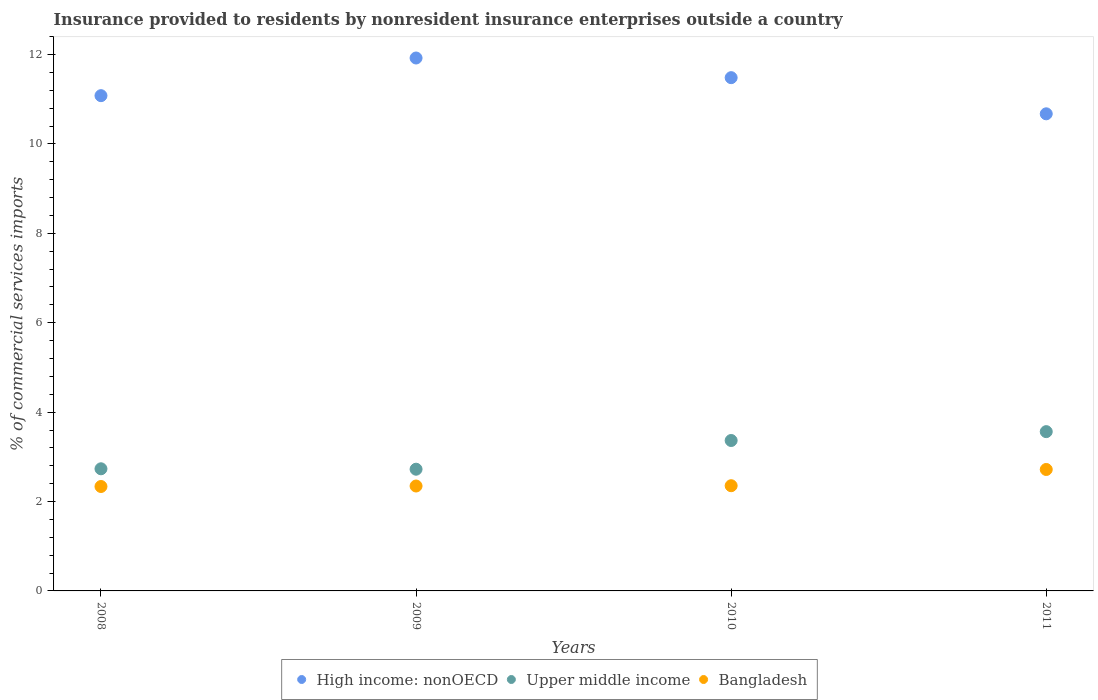What is the Insurance provided to residents in High income: nonOECD in 2011?
Offer a terse response. 10.67. Across all years, what is the maximum Insurance provided to residents in Upper middle income?
Your response must be concise. 3.56. Across all years, what is the minimum Insurance provided to residents in Upper middle income?
Offer a terse response. 2.72. In which year was the Insurance provided to residents in High income: nonOECD minimum?
Make the answer very short. 2011. What is the total Insurance provided to residents in High income: nonOECD in the graph?
Give a very brief answer. 45.16. What is the difference between the Insurance provided to residents in High income: nonOECD in 2008 and that in 2011?
Your answer should be compact. 0.41. What is the difference between the Insurance provided to residents in High income: nonOECD in 2011 and the Insurance provided to residents in Bangladesh in 2008?
Provide a short and direct response. 8.34. What is the average Insurance provided to residents in Bangladesh per year?
Your response must be concise. 2.44. In the year 2010, what is the difference between the Insurance provided to residents in High income: nonOECD and Insurance provided to residents in Bangladesh?
Provide a short and direct response. 9.13. In how many years, is the Insurance provided to residents in Bangladesh greater than 9.2 %?
Keep it short and to the point. 0. What is the ratio of the Insurance provided to residents in Bangladesh in 2009 to that in 2011?
Provide a succinct answer. 0.86. Is the difference between the Insurance provided to residents in High income: nonOECD in 2008 and 2011 greater than the difference between the Insurance provided to residents in Bangladesh in 2008 and 2011?
Ensure brevity in your answer.  Yes. What is the difference between the highest and the second highest Insurance provided to residents in High income: nonOECD?
Give a very brief answer. 0.44. What is the difference between the highest and the lowest Insurance provided to residents in High income: nonOECD?
Your response must be concise. 1.25. In how many years, is the Insurance provided to residents in High income: nonOECD greater than the average Insurance provided to residents in High income: nonOECD taken over all years?
Your response must be concise. 2. Does the Insurance provided to residents in High income: nonOECD monotonically increase over the years?
Your answer should be very brief. No. Is the Insurance provided to residents in Bangladesh strictly greater than the Insurance provided to residents in High income: nonOECD over the years?
Provide a succinct answer. No. How many years are there in the graph?
Your answer should be compact. 4. What is the difference between two consecutive major ticks on the Y-axis?
Offer a terse response. 2. Does the graph contain grids?
Offer a terse response. No. Where does the legend appear in the graph?
Provide a short and direct response. Bottom center. How are the legend labels stacked?
Your response must be concise. Horizontal. What is the title of the graph?
Offer a very short reply. Insurance provided to residents by nonresident insurance enterprises outside a country. Does "Brazil" appear as one of the legend labels in the graph?
Your answer should be very brief. No. What is the label or title of the Y-axis?
Keep it short and to the point. % of commercial services imports. What is the % of commercial services imports of High income: nonOECD in 2008?
Provide a succinct answer. 11.08. What is the % of commercial services imports of Upper middle income in 2008?
Your response must be concise. 2.73. What is the % of commercial services imports of Bangladesh in 2008?
Your answer should be very brief. 2.34. What is the % of commercial services imports in High income: nonOECD in 2009?
Make the answer very short. 11.92. What is the % of commercial services imports of Upper middle income in 2009?
Provide a short and direct response. 2.72. What is the % of commercial services imports of Bangladesh in 2009?
Your response must be concise. 2.35. What is the % of commercial services imports in High income: nonOECD in 2010?
Offer a very short reply. 11.48. What is the % of commercial services imports of Upper middle income in 2010?
Your answer should be compact. 3.37. What is the % of commercial services imports in Bangladesh in 2010?
Your response must be concise. 2.35. What is the % of commercial services imports in High income: nonOECD in 2011?
Your answer should be compact. 10.67. What is the % of commercial services imports of Upper middle income in 2011?
Keep it short and to the point. 3.56. What is the % of commercial services imports of Bangladesh in 2011?
Offer a terse response. 2.72. Across all years, what is the maximum % of commercial services imports in High income: nonOECD?
Your answer should be very brief. 11.92. Across all years, what is the maximum % of commercial services imports of Upper middle income?
Provide a short and direct response. 3.56. Across all years, what is the maximum % of commercial services imports of Bangladesh?
Ensure brevity in your answer.  2.72. Across all years, what is the minimum % of commercial services imports in High income: nonOECD?
Give a very brief answer. 10.67. Across all years, what is the minimum % of commercial services imports in Upper middle income?
Give a very brief answer. 2.72. Across all years, what is the minimum % of commercial services imports in Bangladesh?
Make the answer very short. 2.34. What is the total % of commercial services imports of High income: nonOECD in the graph?
Ensure brevity in your answer.  45.16. What is the total % of commercial services imports in Upper middle income in the graph?
Make the answer very short. 12.38. What is the total % of commercial services imports in Bangladesh in the graph?
Give a very brief answer. 9.75. What is the difference between the % of commercial services imports in High income: nonOECD in 2008 and that in 2009?
Offer a very short reply. -0.84. What is the difference between the % of commercial services imports of Upper middle income in 2008 and that in 2009?
Give a very brief answer. 0.01. What is the difference between the % of commercial services imports in Bangladesh in 2008 and that in 2009?
Make the answer very short. -0.01. What is the difference between the % of commercial services imports of High income: nonOECD in 2008 and that in 2010?
Your answer should be very brief. -0.4. What is the difference between the % of commercial services imports of Upper middle income in 2008 and that in 2010?
Keep it short and to the point. -0.63. What is the difference between the % of commercial services imports of Bangladesh in 2008 and that in 2010?
Your response must be concise. -0.02. What is the difference between the % of commercial services imports in High income: nonOECD in 2008 and that in 2011?
Offer a very short reply. 0.41. What is the difference between the % of commercial services imports in Upper middle income in 2008 and that in 2011?
Your answer should be compact. -0.83. What is the difference between the % of commercial services imports in Bangladesh in 2008 and that in 2011?
Your answer should be compact. -0.38. What is the difference between the % of commercial services imports of High income: nonOECD in 2009 and that in 2010?
Ensure brevity in your answer.  0.44. What is the difference between the % of commercial services imports of Upper middle income in 2009 and that in 2010?
Keep it short and to the point. -0.64. What is the difference between the % of commercial services imports in Bangladesh in 2009 and that in 2010?
Provide a short and direct response. -0.01. What is the difference between the % of commercial services imports in High income: nonOECD in 2009 and that in 2011?
Provide a short and direct response. 1.25. What is the difference between the % of commercial services imports in Upper middle income in 2009 and that in 2011?
Offer a terse response. -0.84. What is the difference between the % of commercial services imports in Bangladesh in 2009 and that in 2011?
Your answer should be compact. -0.37. What is the difference between the % of commercial services imports in High income: nonOECD in 2010 and that in 2011?
Provide a short and direct response. 0.81. What is the difference between the % of commercial services imports of Upper middle income in 2010 and that in 2011?
Make the answer very short. -0.2. What is the difference between the % of commercial services imports of Bangladesh in 2010 and that in 2011?
Your response must be concise. -0.36. What is the difference between the % of commercial services imports in High income: nonOECD in 2008 and the % of commercial services imports in Upper middle income in 2009?
Keep it short and to the point. 8.36. What is the difference between the % of commercial services imports of High income: nonOECD in 2008 and the % of commercial services imports of Bangladesh in 2009?
Provide a short and direct response. 8.73. What is the difference between the % of commercial services imports in Upper middle income in 2008 and the % of commercial services imports in Bangladesh in 2009?
Provide a succinct answer. 0.39. What is the difference between the % of commercial services imports of High income: nonOECD in 2008 and the % of commercial services imports of Upper middle income in 2010?
Make the answer very short. 7.72. What is the difference between the % of commercial services imports of High income: nonOECD in 2008 and the % of commercial services imports of Bangladesh in 2010?
Your answer should be very brief. 8.73. What is the difference between the % of commercial services imports in Upper middle income in 2008 and the % of commercial services imports in Bangladesh in 2010?
Keep it short and to the point. 0.38. What is the difference between the % of commercial services imports in High income: nonOECD in 2008 and the % of commercial services imports in Upper middle income in 2011?
Your answer should be very brief. 7.52. What is the difference between the % of commercial services imports of High income: nonOECD in 2008 and the % of commercial services imports of Bangladesh in 2011?
Provide a short and direct response. 8.36. What is the difference between the % of commercial services imports in Upper middle income in 2008 and the % of commercial services imports in Bangladesh in 2011?
Your answer should be very brief. 0.02. What is the difference between the % of commercial services imports in High income: nonOECD in 2009 and the % of commercial services imports in Upper middle income in 2010?
Give a very brief answer. 8.56. What is the difference between the % of commercial services imports in High income: nonOECD in 2009 and the % of commercial services imports in Bangladesh in 2010?
Give a very brief answer. 9.57. What is the difference between the % of commercial services imports of Upper middle income in 2009 and the % of commercial services imports of Bangladesh in 2010?
Offer a terse response. 0.37. What is the difference between the % of commercial services imports of High income: nonOECD in 2009 and the % of commercial services imports of Upper middle income in 2011?
Ensure brevity in your answer.  8.36. What is the difference between the % of commercial services imports in High income: nonOECD in 2009 and the % of commercial services imports in Bangladesh in 2011?
Your answer should be very brief. 9.21. What is the difference between the % of commercial services imports of Upper middle income in 2009 and the % of commercial services imports of Bangladesh in 2011?
Give a very brief answer. 0.01. What is the difference between the % of commercial services imports of High income: nonOECD in 2010 and the % of commercial services imports of Upper middle income in 2011?
Make the answer very short. 7.92. What is the difference between the % of commercial services imports of High income: nonOECD in 2010 and the % of commercial services imports of Bangladesh in 2011?
Provide a succinct answer. 8.77. What is the difference between the % of commercial services imports in Upper middle income in 2010 and the % of commercial services imports in Bangladesh in 2011?
Keep it short and to the point. 0.65. What is the average % of commercial services imports of High income: nonOECD per year?
Provide a succinct answer. 11.29. What is the average % of commercial services imports in Upper middle income per year?
Offer a terse response. 3.1. What is the average % of commercial services imports of Bangladesh per year?
Provide a succinct answer. 2.44. In the year 2008, what is the difference between the % of commercial services imports in High income: nonOECD and % of commercial services imports in Upper middle income?
Your response must be concise. 8.35. In the year 2008, what is the difference between the % of commercial services imports in High income: nonOECD and % of commercial services imports in Bangladesh?
Make the answer very short. 8.74. In the year 2008, what is the difference between the % of commercial services imports in Upper middle income and % of commercial services imports in Bangladesh?
Offer a very short reply. 0.4. In the year 2009, what is the difference between the % of commercial services imports in High income: nonOECD and % of commercial services imports in Upper middle income?
Provide a succinct answer. 9.2. In the year 2009, what is the difference between the % of commercial services imports of High income: nonOECD and % of commercial services imports of Bangladesh?
Keep it short and to the point. 9.58. In the year 2009, what is the difference between the % of commercial services imports of Upper middle income and % of commercial services imports of Bangladesh?
Your response must be concise. 0.38. In the year 2010, what is the difference between the % of commercial services imports of High income: nonOECD and % of commercial services imports of Upper middle income?
Keep it short and to the point. 8.12. In the year 2010, what is the difference between the % of commercial services imports in High income: nonOECD and % of commercial services imports in Bangladesh?
Your answer should be very brief. 9.13. In the year 2010, what is the difference between the % of commercial services imports in Upper middle income and % of commercial services imports in Bangladesh?
Make the answer very short. 1.01. In the year 2011, what is the difference between the % of commercial services imports of High income: nonOECD and % of commercial services imports of Upper middle income?
Give a very brief answer. 7.11. In the year 2011, what is the difference between the % of commercial services imports in High income: nonOECD and % of commercial services imports in Bangladesh?
Ensure brevity in your answer.  7.96. In the year 2011, what is the difference between the % of commercial services imports in Upper middle income and % of commercial services imports in Bangladesh?
Your answer should be very brief. 0.85. What is the ratio of the % of commercial services imports of High income: nonOECD in 2008 to that in 2009?
Keep it short and to the point. 0.93. What is the ratio of the % of commercial services imports of Upper middle income in 2008 to that in 2009?
Give a very brief answer. 1. What is the ratio of the % of commercial services imports of Bangladesh in 2008 to that in 2009?
Give a very brief answer. 1. What is the ratio of the % of commercial services imports in High income: nonOECD in 2008 to that in 2010?
Make the answer very short. 0.96. What is the ratio of the % of commercial services imports of Upper middle income in 2008 to that in 2010?
Your response must be concise. 0.81. What is the ratio of the % of commercial services imports of High income: nonOECD in 2008 to that in 2011?
Keep it short and to the point. 1.04. What is the ratio of the % of commercial services imports of Upper middle income in 2008 to that in 2011?
Your answer should be very brief. 0.77. What is the ratio of the % of commercial services imports in Bangladesh in 2008 to that in 2011?
Make the answer very short. 0.86. What is the ratio of the % of commercial services imports in High income: nonOECD in 2009 to that in 2010?
Give a very brief answer. 1.04. What is the ratio of the % of commercial services imports of Upper middle income in 2009 to that in 2010?
Your response must be concise. 0.81. What is the ratio of the % of commercial services imports of High income: nonOECD in 2009 to that in 2011?
Offer a terse response. 1.12. What is the ratio of the % of commercial services imports in Upper middle income in 2009 to that in 2011?
Keep it short and to the point. 0.76. What is the ratio of the % of commercial services imports of Bangladesh in 2009 to that in 2011?
Offer a very short reply. 0.86. What is the ratio of the % of commercial services imports in High income: nonOECD in 2010 to that in 2011?
Your answer should be very brief. 1.08. What is the ratio of the % of commercial services imports of Upper middle income in 2010 to that in 2011?
Make the answer very short. 0.94. What is the ratio of the % of commercial services imports of Bangladesh in 2010 to that in 2011?
Offer a very short reply. 0.87. What is the difference between the highest and the second highest % of commercial services imports in High income: nonOECD?
Give a very brief answer. 0.44. What is the difference between the highest and the second highest % of commercial services imports in Upper middle income?
Your answer should be very brief. 0.2. What is the difference between the highest and the second highest % of commercial services imports of Bangladesh?
Offer a terse response. 0.36. What is the difference between the highest and the lowest % of commercial services imports in High income: nonOECD?
Your answer should be compact. 1.25. What is the difference between the highest and the lowest % of commercial services imports in Upper middle income?
Give a very brief answer. 0.84. What is the difference between the highest and the lowest % of commercial services imports in Bangladesh?
Offer a terse response. 0.38. 